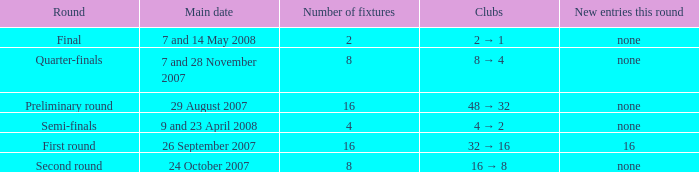What is the New entries this round when the round is the semi-finals? None. 